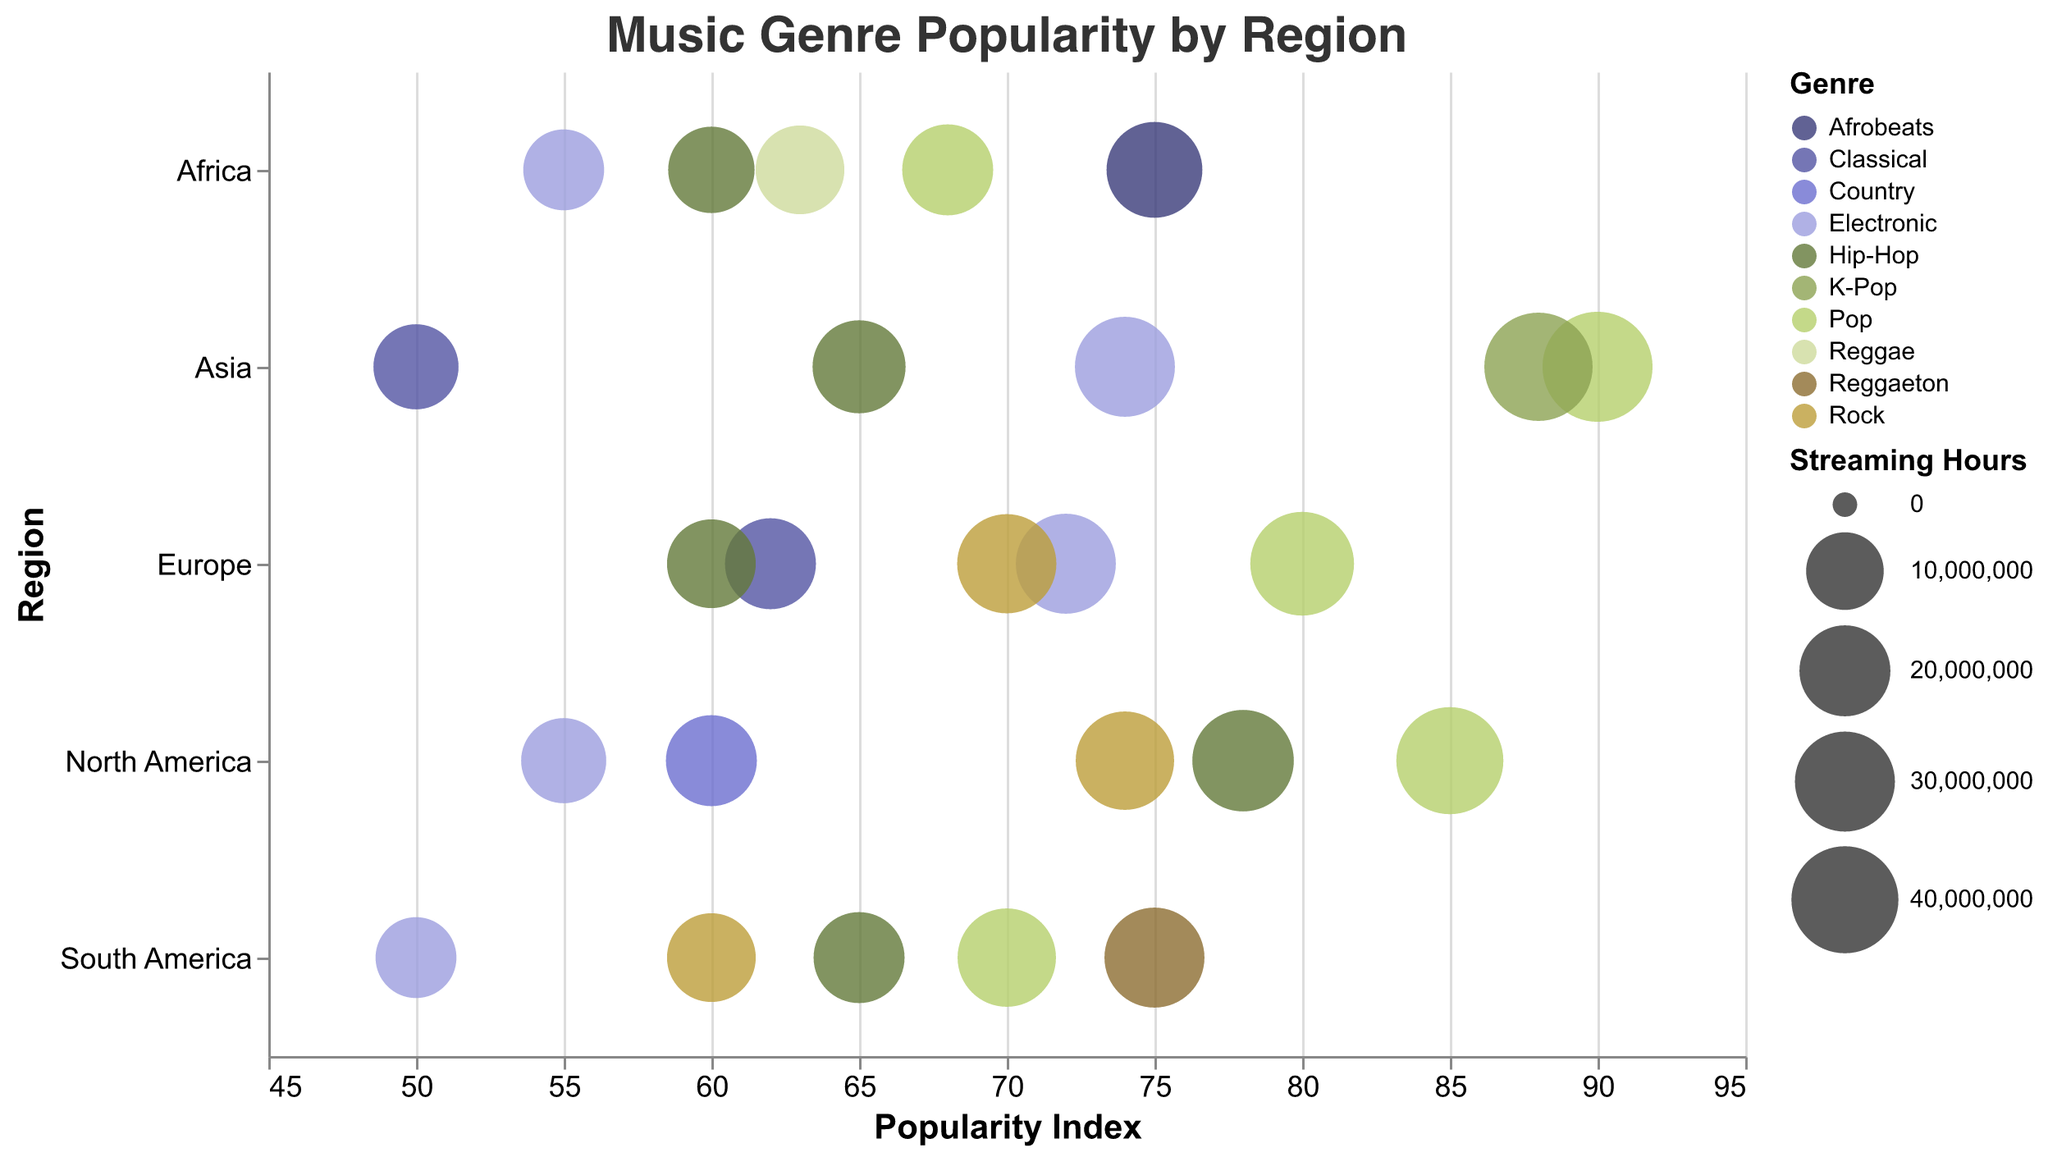What is the most popular genre in Asia based on the popularity index? Check the highest Popularity Index value for the Asia region. Pop has the highest Popularity Index of 90.
Answer: Pop Which genre in North America has the highest Streaming Hours? Look at the Streaming Hours for each genre in North America. Pop has the highest Streaming Hours with 40,000,000 hours.
Answer: Pop Compare the Pop genre's popularity between North America and Europe. Which region has a higher Popularity Index? Compare the Popularity Index values for the Pop genre in North America and Europe. North America has 85, whereas Europe has 80.
Answer: North America How does the Streaming Hours of Pop in Asia compare to Pop in South America? Compare the Streaming Hours values for the Pop genre in Asia and South America. Asia has 45,000,000 hours while South America has 28,000,000 hours.
Answer: Asia has more Which region has the least Streaming Hours for Electronic music? Look at the Streaming Hours for the Electronic genre in each region. South America has the least with 12,000,000 hours.
Answer: South America What is the range of the Popularity Index for Hip-Hop across all regions? Look at the Popularity Index for Hip-Hop in all regions: North America (78), Europe (60), Asia (65), South America (65), Africa (60). The range is 78 - 60 = 18.
Answer: 18 What genre in Africa has the highest Popularity Index, and what is it? Look for the highest Popularity Index in the Africa region. Afrobeats has the highest Popularity Index at 75.
Answer: Afrobeats, 75 What is the average Popularity Index of Pop genre across all regions? Sum the Popularity Indexes for Pop in all regions and divide by the number of regions: (85 + 80 + 90 + 70 + 68)/5 = 78.6.
Answer: 78.6 Which region has the highest Streaming Hours for genres with a Popularity Index above 80? Identify regions with genres having a Popularity Index above 80 and check the Streaming Hours: North America (Pop 40,000,000), Asia (Pop 45,000,000, K-Pop 42,000,000). Asia has the highest Streaming Hours with 45000000 hours for Pop.
Answer: Asia What genre in Europe has the least Popularity Index and what is it? Look for the genre in Europe with the lowest Popularity Index. Hip-Hop has the lowest at 60.
Answer: Hip-Hop, 60 